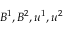Convert formula to latex. <formula><loc_0><loc_0><loc_500><loc_500>B ^ { 1 } , B ^ { 2 } , u ^ { 1 } , u ^ { 2 }</formula> 